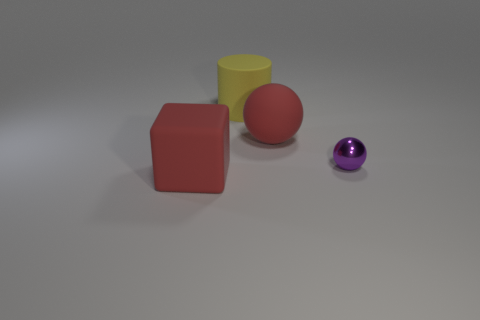Add 3 tiny purple objects. How many objects exist? 7 Subtract all cubes. How many objects are left? 3 Subtract 1 purple balls. How many objects are left? 3 Subtract all purple spheres. Subtract all big rubber cylinders. How many objects are left? 2 Add 4 purple shiny things. How many purple shiny things are left? 5 Add 3 large matte objects. How many large matte objects exist? 6 